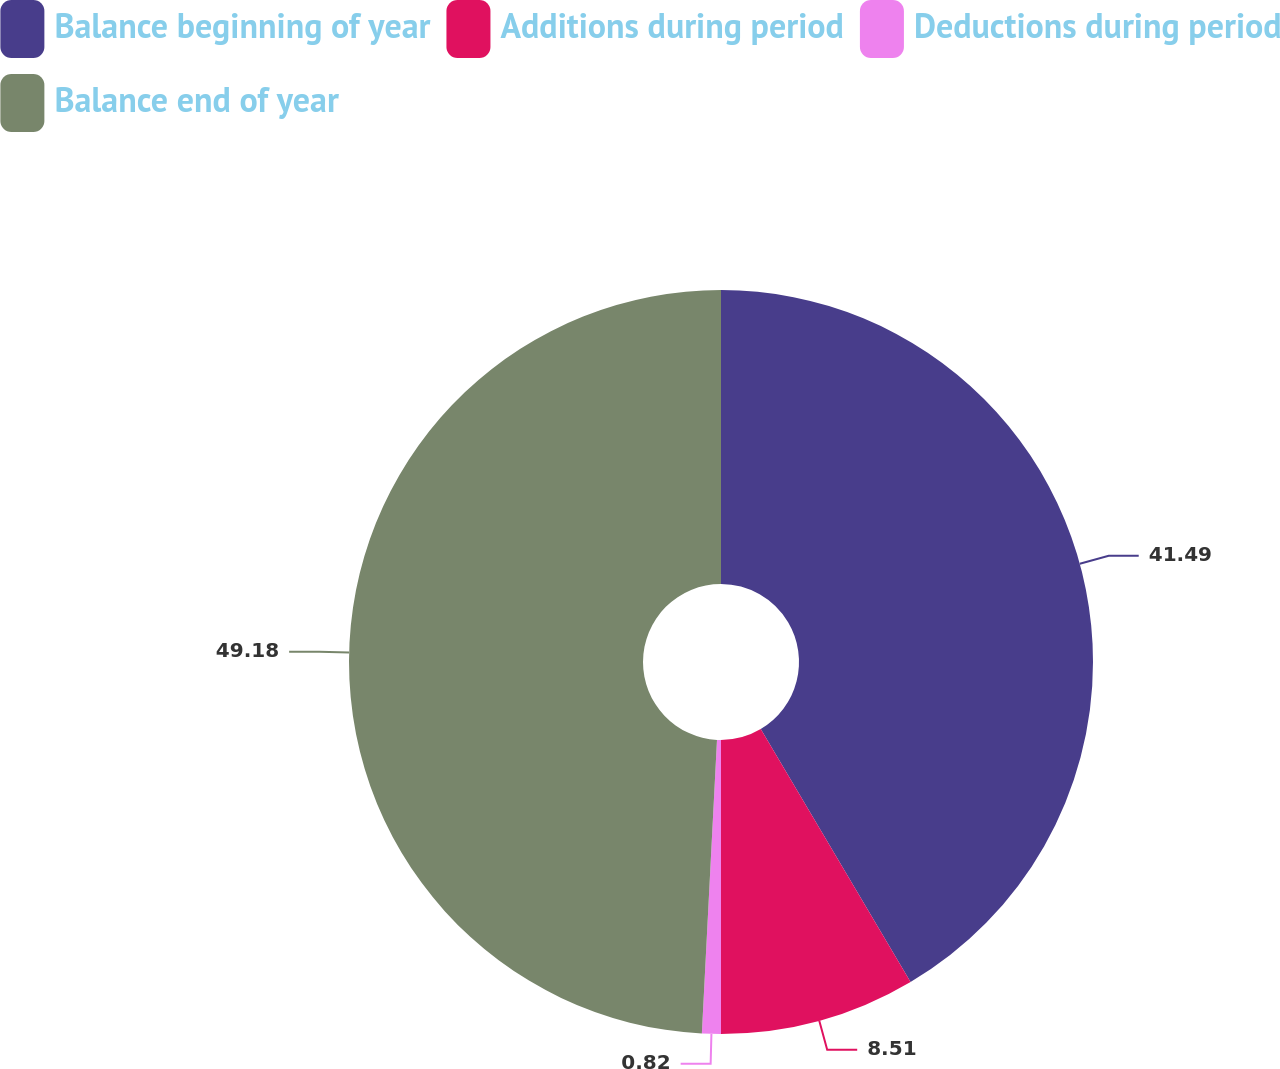Convert chart. <chart><loc_0><loc_0><loc_500><loc_500><pie_chart><fcel>Balance beginning of year<fcel>Additions during period<fcel>Deductions during period<fcel>Balance end of year<nl><fcel>41.49%<fcel>8.51%<fcel>0.82%<fcel>49.18%<nl></chart> 